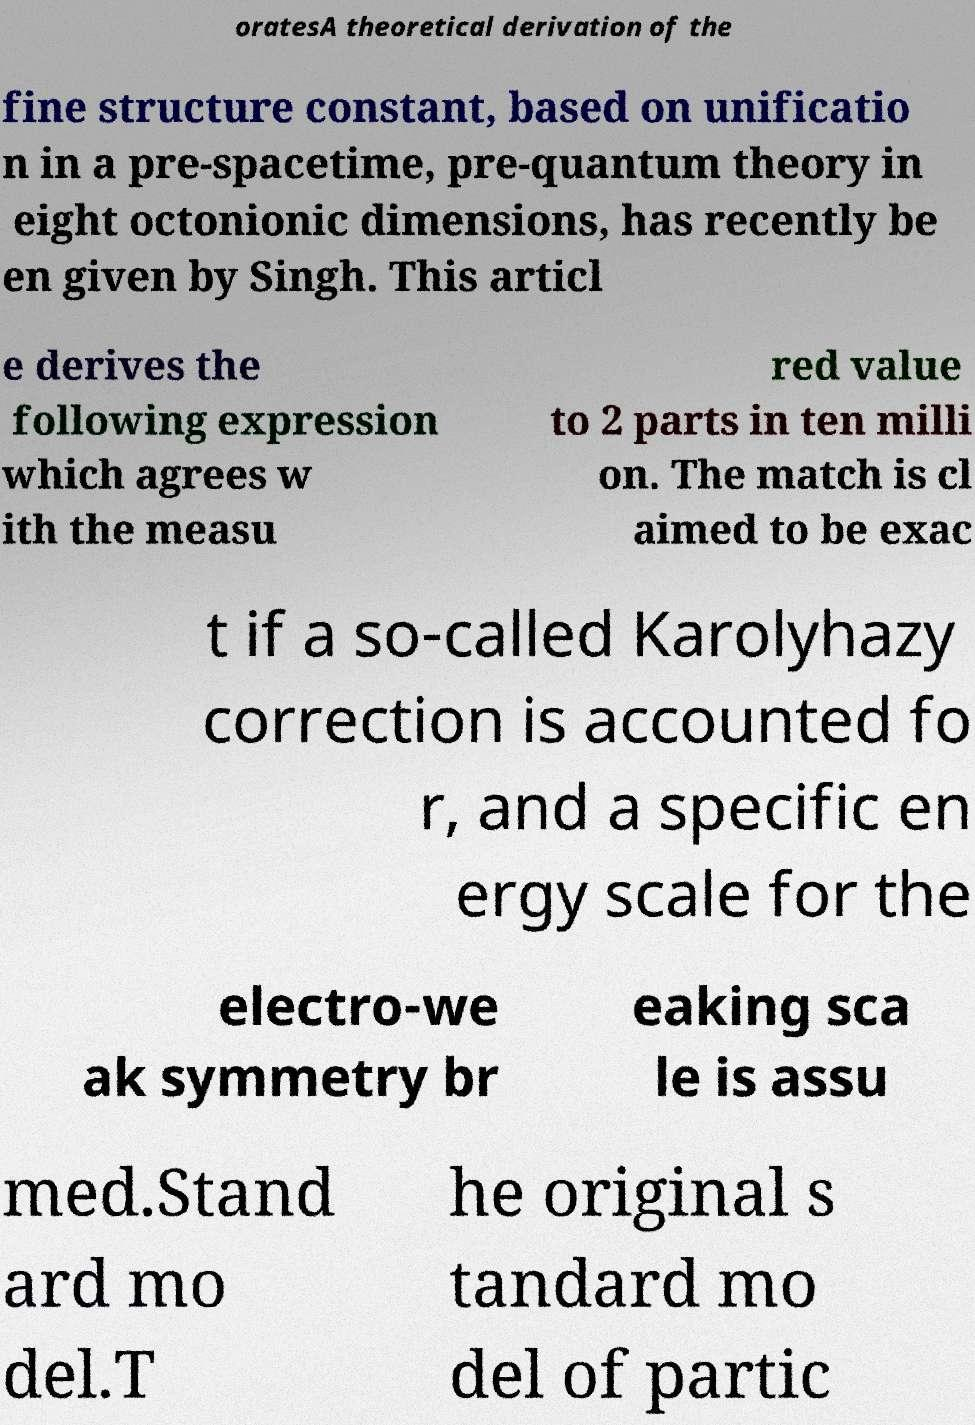Can you accurately transcribe the text from the provided image for me? oratesA theoretical derivation of the fine structure constant, based on unificatio n in a pre-spacetime, pre-quantum theory in eight octonionic dimensions, has recently be en given by Singh. This articl e derives the following expression which agrees w ith the measu red value to 2 parts in ten milli on. The match is cl aimed to be exac t if a so-called Karolyhazy correction is accounted fo r, and a specific en ergy scale for the electro-we ak symmetry br eaking sca le is assu med.Stand ard mo del.T he original s tandard mo del of partic 